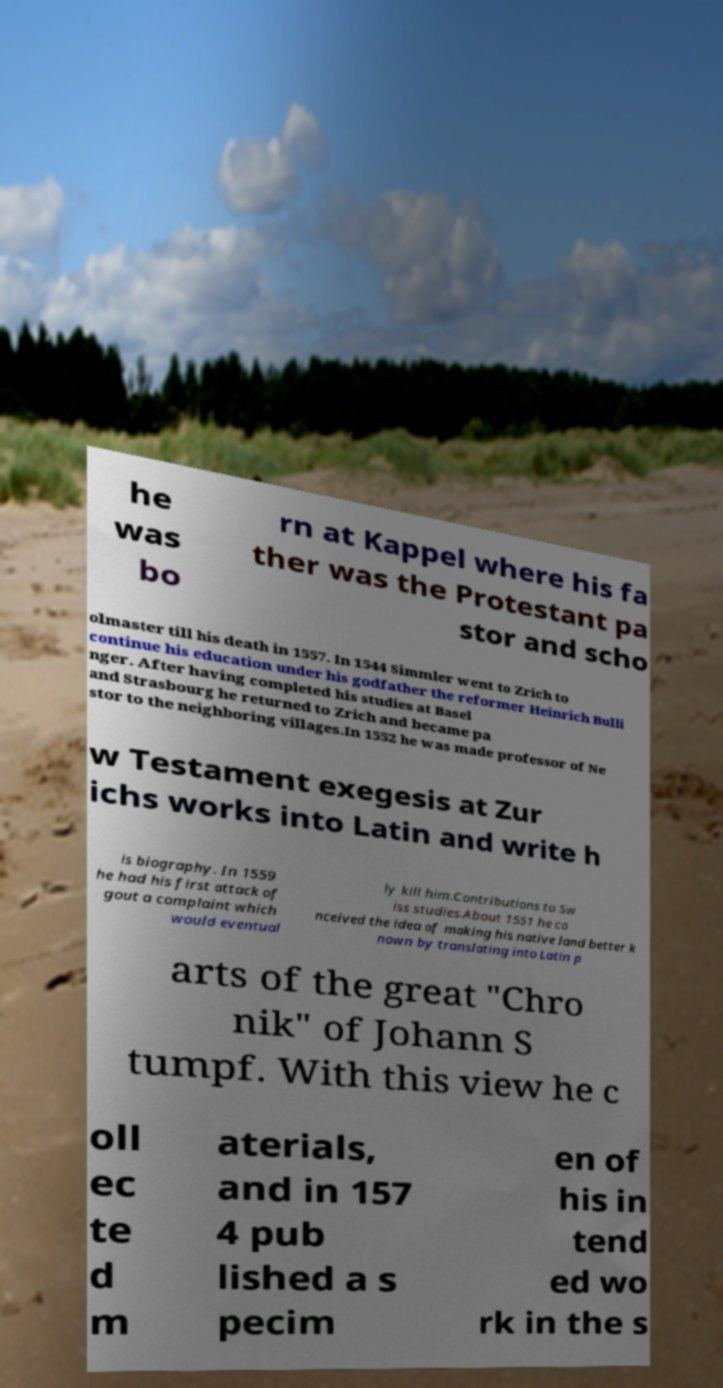Can you accurately transcribe the text from the provided image for me? he was bo rn at Kappel where his fa ther was the Protestant pa stor and scho olmaster till his death in 1557. In 1544 Simmler went to Zrich to continue his education under his godfather the reformer Heinrich Bulli nger. After having completed his studies at Basel and Strasbourg he returned to Zrich and became pa stor to the neighboring villages.In 1552 he was made professor of Ne w Testament exegesis at Zur ichs works into Latin and write h is biography. In 1559 he had his first attack of gout a complaint which would eventual ly kill him.Contributions to Sw iss studies.About 1551 he co nceived the idea of making his native land better k nown by translating into Latin p arts of the great "Chro nik" of Johann S tumpf. With this view he c oll ec te d m aterials, and in 157 4 pub lished a s pecim en of his in tend ed wo rk in the s 